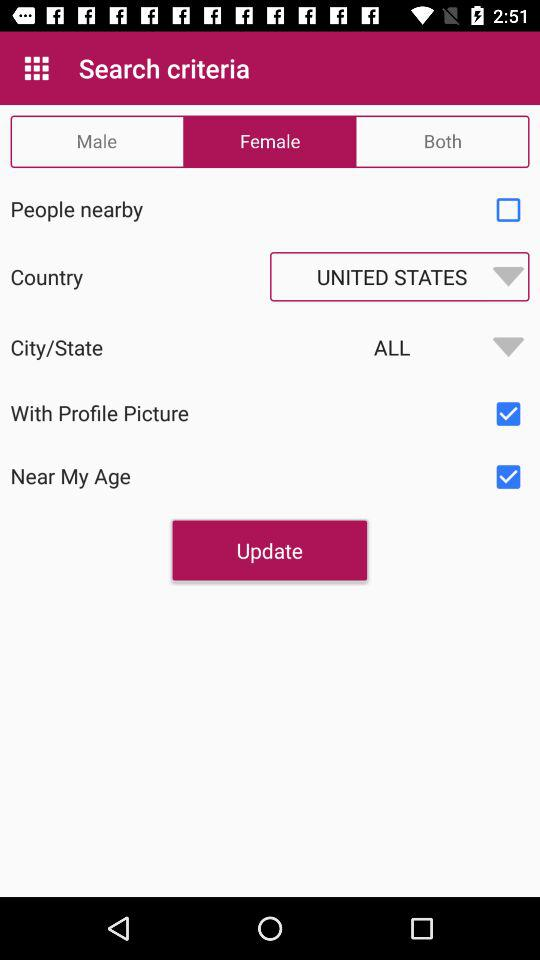Which country has been selected? The selected country is the United States. 